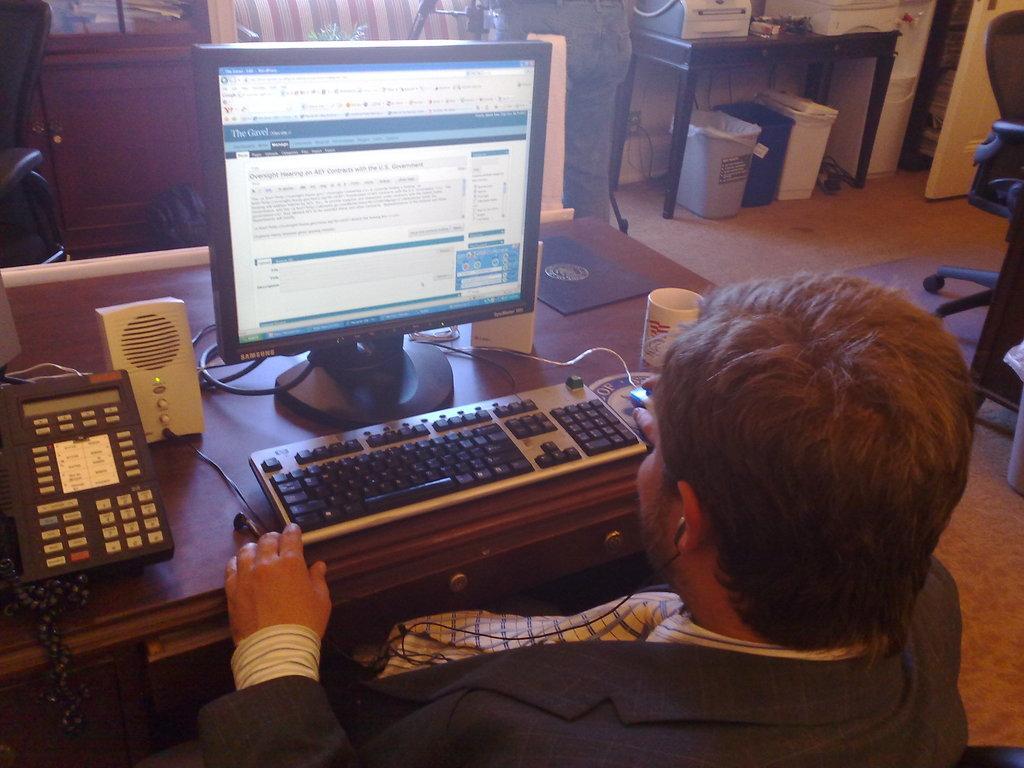In one or two sentences, can you explain what this image depicts? In this picture we can see a man who is sitting on the chair. This is the table. On the table there is a monitor, keyboard, mouse, cup, and some electronic devices. This is the floor and these are the bins. Here we can see a cupboard. 